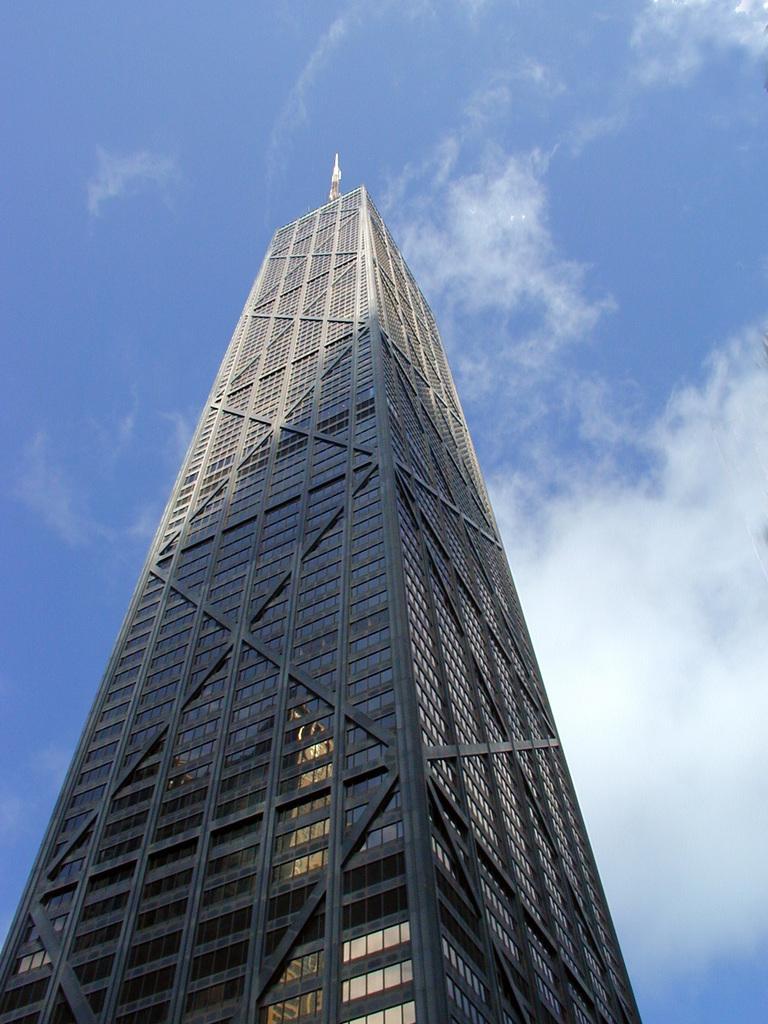Could you give a brief overview of what you see in this image? Here in this picture we can see a building tower present over there and we can see clouds in the sky over there. 